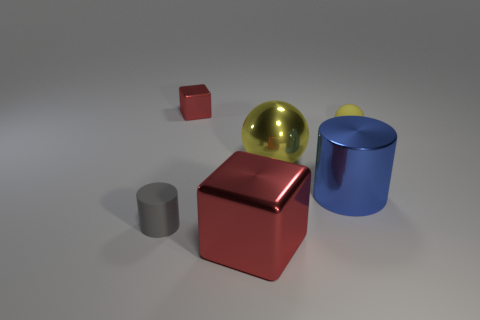Are there fewer gray cylinders than large objects?
Offer a terse response. Yes. The red metallic thing that is in front of the matte object that is left of the tiny ball is what shape?
Your response must be concise. Cube. Are there any big balls right of the big yellow thing?
Your answer should be compact. No. What is the color of the metal ball that is the same size as the shiny cylinder?
Your answer should be compact. Yellow. How many other gray things have the same material as the tiny gray object?
Offer a very short reply. 0. Is there a gray cylinder that has the same size as the yellow metallic sphere?
Your answer should be very brief. No. There is a large shiny object to the left of the yellow shiny ball; is its color the same as the tiny shiny block?
Make the answer very short. Yes. How many things are big red cubes or small red metal things?
Provide a short and direct response. 2. Does the shiny thing behind the rubber sphere have the same size as the yellow metallic object?
Keep it short and to the point. No. There is a thing that is in front of the blue cylinder and on the right side of the small metal cube; what size is it?
Keep it short and to the point. Large. 